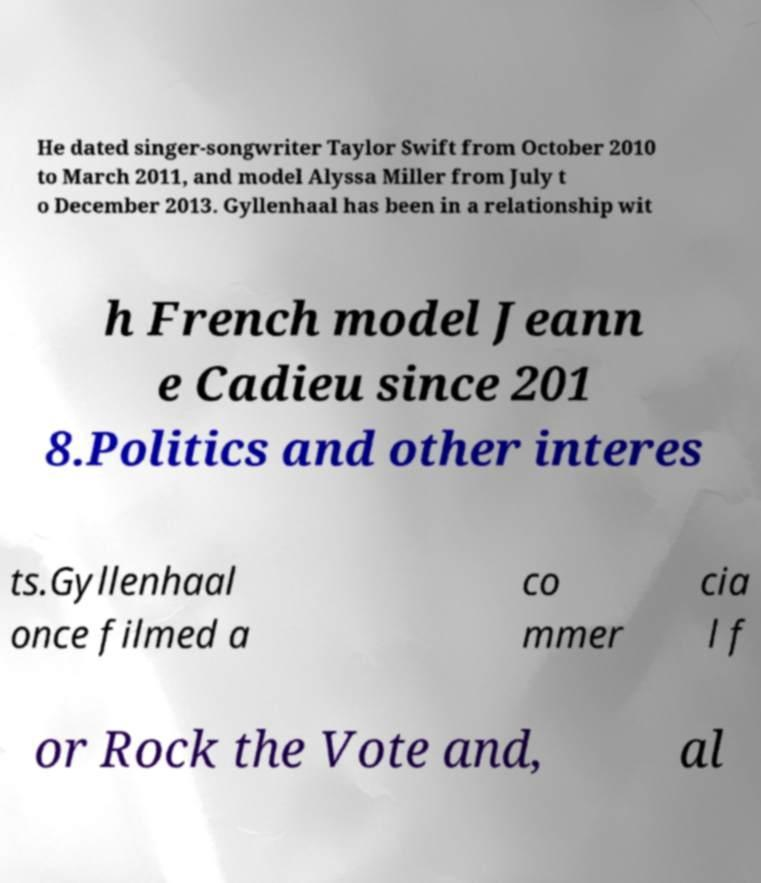There's text embedded in this image that I need extracted. Can you transcribe it verbatim? He dated singer-songwriter Taylor Swift from October 2010 to March 2011, and model Alyssa Miller from July t o December 2013. Gyllenhaal has been in a relationship wit h French model Jeann e Cadieu since 201 8.Politics and other interes ts.Gyllenhaal once filmed a co mmer cia l f or Rock the Vote and, al 